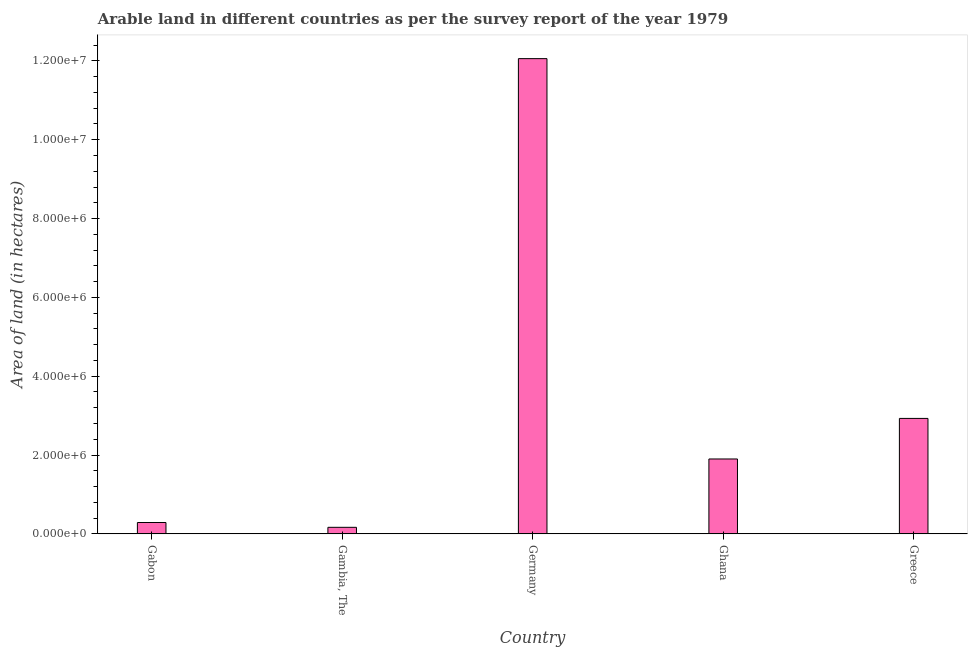Does the graph contain grids?
Make the answer very short. No. What is the title of the graph?
Your response must be concise. Arable land in different countries as per the survey report of the year 1979. What is the label or title of the Y-axis?
Your response must be concise. Area of land (in hectares). What is the area of land in Ghana?
Your answer should be compact. 1.90e+06. Across all countries, what is the maximum area of land?
Provide a succinct answer. 1.21e+07. Across all countries, what is the minimum area of land?
Provide a short and direct response. 1.66e+05. In which country was the area of land minimum?
Keep it short and to the point. Gambia, The. What is the sum of the area of land?
Make the answer very short. 1.73e+07. What is the difference between the area of land in Gabon and Gambia, The?
Ensure brevity in your answer.  1.22e+05. What is the average area of land per country?
Provide a succinct answer. 3.47e+06. What is the median area of land?
Offer a very short reply. 1.90e+06. What is the ratio of the area of land in Gambia, The to that in Greece?
Provide a succinct answer. 0.06. Is the area of land in Gabon less than that in Gambia, The?
Provide a short and direct response. No. Is the difference between the area of land in Germany and Ghana greater than the difference between any two countries?
Provide a short and direct response. No. What is the difference between the highest and the second highest area of land?
Provide a short and direct response. 9.13e+06. Is the sum of the area of land in Gabon and Greece greater than the maximum area of land across all countries?
Ensure brevity in your answer.  No. What is the difference between the highest and the lowest area of land?
Provide a short and direct response. 1.19e+07. Are all the bars in the graph horizontal?
Your answer should be very brief. No. How many countries are there in the graph?
Make the answer very short. 5. What is the Area of land (in hectares) in Gabon?
Your response must be concise. 2.88e+05. What is the Area of land (in hectares) of Gambia, The?
Provide a short and direct response. 1.66e+05. What is the Area of land (in hectares) of Germany?
Ensure brevity in your answer.  1.21e+07. What is the Area of land (in hectares) of Ghana?
Ensure brevity in your answer.  1.90e+06. What is the Area of land (in hectares) of Greece?
Your answer should be compact. 2.93e+06. What is the difference between the Area of land (in hectares) in Gabon and Gambia, The?
Give a very brief answer. 1.22e+05. What is the difference between the Area of land (in hectares) in Gabon and Germany?
Ensure brevity in your answer.  -1.18e+07. What is the difference between the Area of land (in hectares) in Gabon and Ghana?
Provide a succinct answer. -1.61e+06. What is the difference between the Area of land (in hectares) in Gabon and Greece?
Keep it short and to the point. -2.64e+06. What is the difference between the Area of land (in hectares) in Gambia, The and Germany?
Make the answer very short. -1.19e+07. What is the difference between the Area of land (in hectares) in Gambia, The and Ghana?
Keep it short and to the point. -1.73e+06. What is the difference between the Area of land (in hectares) in Gambia, The and Greece?
Ensure brevity in your answer.  -2.76e+06. What is the difference between the Area of land (in hectares) in Germany and Ghana?
Ensure brevity in your answer.  1.02e+07. What is the difference between the Area of land (in hectares) in Germany and Greece?
Provide a short and direct response. 9.13e+06. What is the difference between the Area of land (in hectares) in Ghana and Greece?
Provide a succinct answer. -1.03e+06. What is the ratio of the Area of land (in hectares) in Gabon to that in Gambia, The?
Provide a succinct answer. 1.74. What is the ratio of the Area of land (in hectares) in Gabon to that in Germany?
Your answer should be compact. 0.02. What is the ratio of the Area of land (in hectares) in Gabon to that in Ghana?
Provide a short and direct response. 0.15. What is the ratio of the Area of land (in hectares) in Gabon to that in Greece?
Make the answer very short. 0.1. What is the ratio of the Area of land (in hectares) in Gambia, The to that in Germany?
Make the answer very short. 0.01. What is the ratio of the Area of land (in hectares) in Gambia, The to that in Ghana?
Offer a terse response. 0.09. What is the ratio of the Area of land (in hectares) in Gambia, The to that in Greece?
Your answer should be very brief. 0.06. What is the ratio of the Area of land (in hectares) in Germany to that in Ghana?
Keep it short and to the point. 6.35. What is the ratio of the Area of land (in hectares) in Germany to that in Greece?
Make the answer very short. 4.12. What is the ratio of the Area of land (in hectares) in Ghana to that in Greece?
Ensure brevity in your answer.  0.65. 